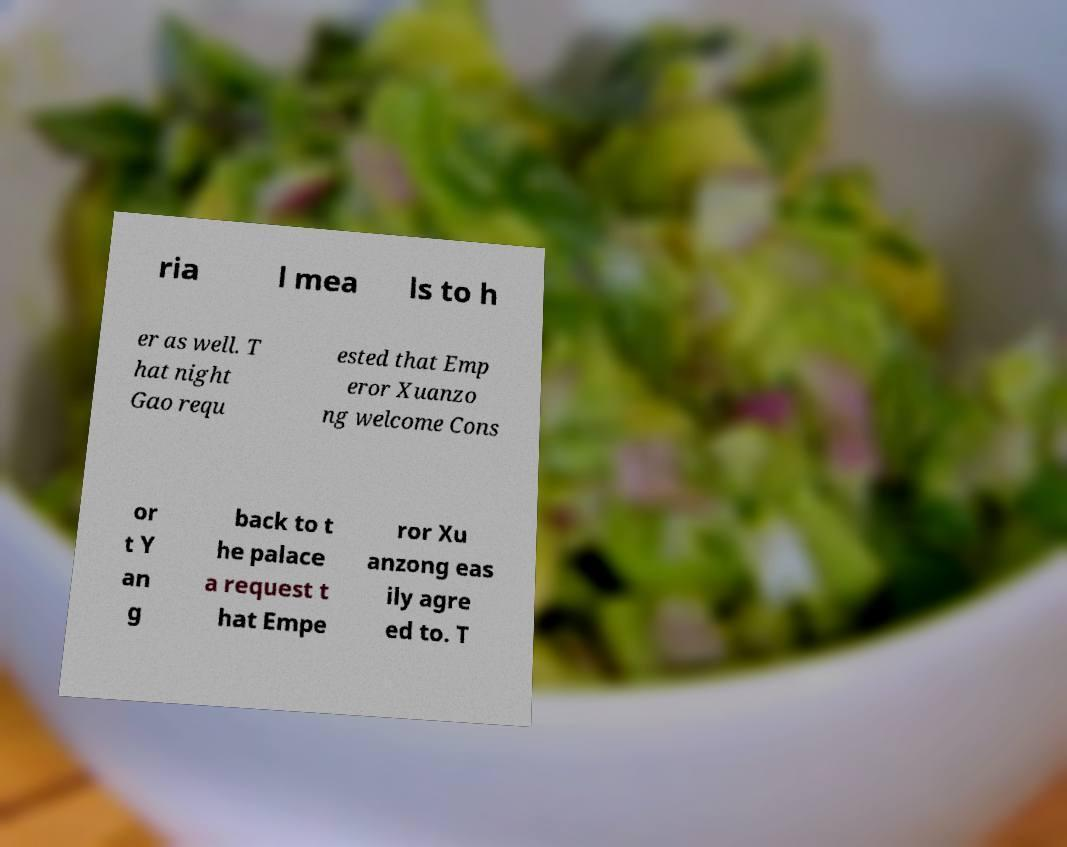Please read and relay the text visible in this image. What does it say? ria l mea ls to h er as well. T hat night Gao requ ested that Emp eror Xuanzo ng welcome Cons or t Y an g back to t he palace a request t hat Empe ror Xu anzong eas ily agre ed to. T 